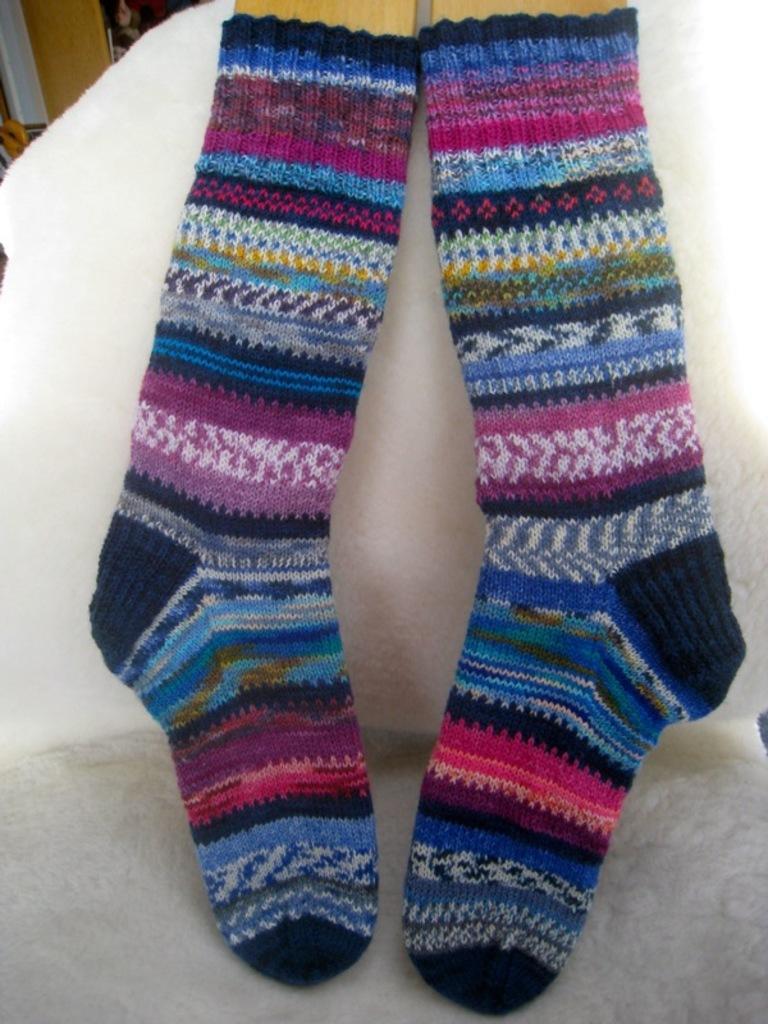Please provide a concise description of this image. In this image we can see a pair of socks on the chair. 